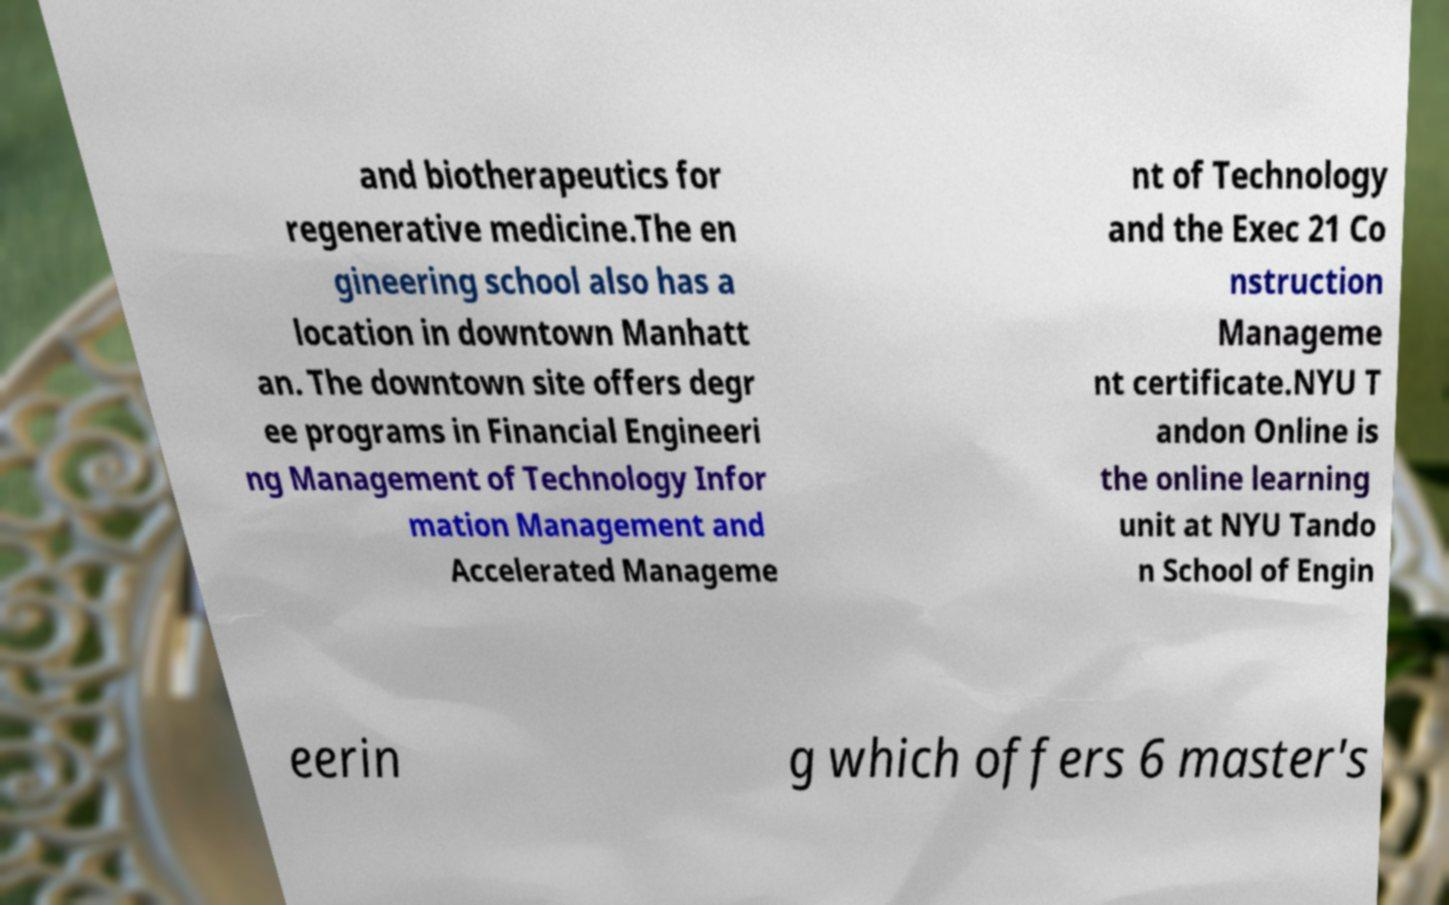Can you read and provide the text displayed in the image?This photo seems to have some interesting text. Can you extract and type it out for me? and biotherapeutics for regenerative medicine.The en gineering school also has a location in downtown Manhatt an. The downtown site offers degr ee programs in Financial Engineeri ng Management of Technology Infor mation Management and Accelerated Manageme nt of Technology and the Exec 21 Co nstruction Manageme nt certificate.NYU T andon Online is the online learning unit at NYU Tando n School of Engin eerin g which offers 6 master's 